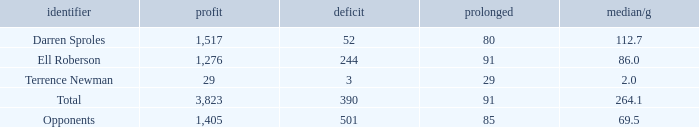What's the sum of all average yards gained when the gained yards is under 1,276 and lost more than 3 yards? None. Could you help me parse every detail presented in this table? {'header': ['identifier', 'profit', 'deficit', 'prolonged', 'median/g'], 'rows': [['Darren Sproles', '1,517', '52', '80', '112.7'], ['Ell Roberson', '1,276', '244', '91', '86.0'], ['Terrence Newman', '29', '3', '29', '2.0'], ['Total', '3,823', '390', '91', '264.1'], ['Opponents', '1,405', '501', '85', '69.5']]} 